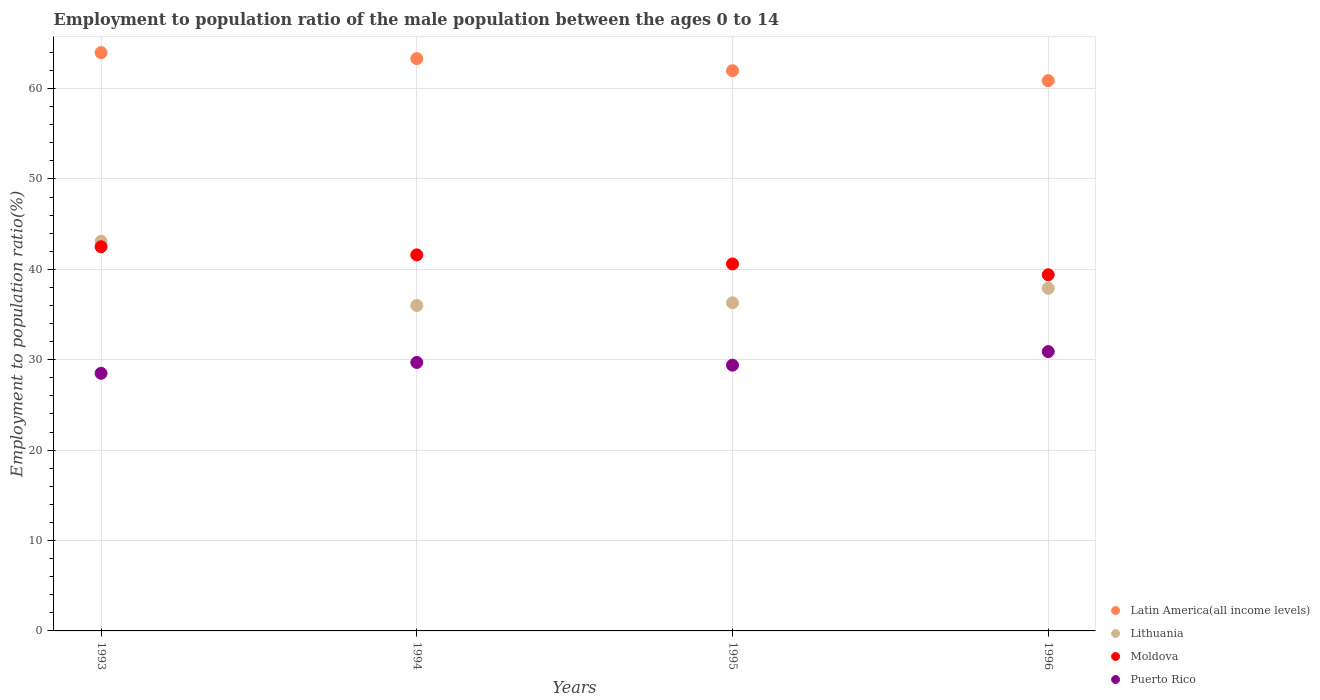What is the employment to population ratio in Puerto Rico in 1996?
Offer a terse response. 30.9. Across all years, what is the maximum employment to population ratio in Moldova?
Offer a very short reply. 42.5. Across all years, what is the minimum employment to population ratio in Puerto Rico?
Your answer should be very brief. 28.5. In which year was the employment to population ratio in Latin America(all income levels) maximum?
Keep it short and to the point. 1993. What is the total employment to population ratio in Moldova in the graph?
Your answer should be very brief. 164.1. What is the difference between the employment to population ratio in Latin America(all income levels) in 1994 and that in 1996?
Make the answer very short. 2.44. What is the difference between the employment to population ratio in Puerto Rico in 1993 and the employment to population ratio in Lithuania in 1995?
Your answer should be compact. -7.8. What is the average employment to population ratio in Puerto Rico per year?
Ensure brevity in your answer.  29.63. In how many years, is the employment to population ratio in Latin America(all income levels) greater than 56 %?
Give a very brief answer. 4. What is the ratio of the employment to population ratio in Lithuania in 1993 to that in 1995?
Provide a succinct answer. 1.19. Is the difference between the employment to population ratio in Moldova in 1993 and 1994 greater than the difference between the employment to population ratio in Puerto Rico in 1993 and 1994?
Your response must be concise. Yes. What is the difference between the highest and the second highest employment to population ratio in Lithuania?
Give a very brief answer. 5.2. What is the difference between the highest and the lowest employment to population ratio in Latin America(all income levels)?
Your response must be concise. 3.1. Is it the case that in every year, the sum of the employment to population ratio in Moldova and employment to population ratio in Lithuania  is greater than the sum of employment to population ratio in Latin America(all income levels) and employment to population ratio in Puerto Rico?
Provide a short and direct response. Yes. Is the employment to population ratio in Latin America(all income levels) strictly greater than the employment to population ratio in Lithuania over the years?
Offer a terse response. Yes. Does the graph contain grids?
Ensure brevity in your answer.  Yes. What is the title of the graph?
Give a very brief answer. Employment to population ratio of the male population between the ages 0 to 14. Does "Morocco" appear as one of the legend labels in the graph?
Provide a succinct answer. No. What is the label or title of the Y-axis?
Provide a succinct answer. Employment to population ratio(%). What is the Employment to population ratio(%) of Latin America(all income levels) in 1993?
Your answer should be very brief. 63.98. What is the Employment to population ratio(%) of Lithuania in 1993?
Your answer should be very brief. 43.1. What is the Employment to population ratio(%) of Moldova in 1993?
Your response must be concise. 42.5. What is the Employment to population ratio(%) in Latin America(all income levels) in 1994?
Your answer should be very brief. 63.31. What is the Employment to population ratio(%) in Moldova in 1994?
Offer a terse response. 41.6. What is the Employment to population ratio(%) in Puerto Rico in 1994?
Ensure brevity in your answer.  29.7. What is the Employment to population ratio(%) in Latin America(all income levels) in 1995?
Ensure brevity in your answer.  61.98. What is the Employment to population ratio(%) in Lithuania in 1995?
Your answer should be compact. 36.3. What is the Employment to population ratio(%) of Moldova in 1995?
Keep it short and to the point. 40.6. What is the Employment to population ratio(%) of Puerto Rico in 1995?
Offer a terse response. 29.4. What is the Employment to population ratio(%) in Latin America(all income levels) in 1996?
Ensure brevity in your answer.  60.87. What is the Employment to population ratio(%) of Lithuania in 1996?
Your response must be concise. 37.9. What is the Employment to population ratio(%) of Moldova in 1996?
Offer a terse response. 39.4. What is the Employment to population ratio(%) of Puerto Rico in 1996?
Your answer should be very brief. 30.9. Across all years, what is the maximum Employment to population ratio(%) of Latin America(all income levels)?
Provide a short and direct response. 63.98. Across all years, what is the maximum Employment to population ratio(%) of Lithuania?
Provide a short and direct response. 43.1. Across all years, what is the maximum Employment to population ratio(%) of Moldova?
Offer a very short reply. 42.5. Across all years, what is the maximum Employment to population ratio(%) in Puerto Rico?
Your response must be concise. 30.9. Across all years, what is the minimum Employment to population ratio(%) in Latin America(all income levels)?
Give a very brief answer. 60.87. Across all years, what is the minimum Employment to population ratio(%) of Lithuania?
Provide a succinct answer. 36. Across all years, what is the minimum Employment to population ratio(%) in Moldova?
Your answer should be compact. 39.4. Across all years, what is the minimum Employment to population ratio(%) in Puerto Rico?
Ensure brevity in your answer.  28.5. What is the total Employment to population ratio(%) of Latin America(all income levels) in the graph?
Your answer should be very brief. 250.14. What is the total Employment to population ratio(%) of Lithuania in the graph?
Provide a succinct answer. 153.3. What is the total Employment to population ratio(%) in Moldova in the graph?
Make the answer very short. 164.1. What is the total Employment to population ratio(%) of Puerto Rico in the graph?
Provide a succinct answer. 118.5. What is the difference between the Employment to population ratio(%) in Latin America(all income levels) in 1993 and that in 1994?
Offer a very short reply. 0.67. What is the difference between the Employment to population ratio(%) in Lithuania in 1993 and that in 1994?
Your answer should be compact. 7.1. What is the difference between the Employment to population ratio(%) of Latin America(all income levels) in 1993 and that in 1995?
Keep it short and to the point. 2. What is the difference between the Employment to population ratio(%) of Latin America(all income levels) in 1993 and that in 1996?
Offer a very short reply. 3.1. What is the difference between the Employment to population ratio(%) in Lithuania in 1993 and that in 1996?
Keep it short and to the point. 5.2. What is the difference between the Employment to population ratio(%) of Moldova in 1993 and that in 1996?
Provide a succinct answer. 3.1. What is the difference between the Employment to population ratio(%) of Puerto Rico in 1993 and that in 1996?
Your answer should be very brief. -2.4. What is the difference between the Employment to population ratio(%) in Latin America(all income levels) in 1994 and that in 1995?
Keep it short and to the point. 1.33. What is the difference between the Employment to population ratio(%) in Latin America(all income levels) in 1994 and that in 1996?
Your answer should be compact. 2.44. What is the difference between the Employment to population ratio(%) in Lithuania in 1994 and that in 1996?
Provide a succinct answer. -1.9. What is the difference between the Employment to population ratio(%) of Moldova in 1994 and that in 1996?
Your answer should be very brief. 2.2. What is the difference between the Employment to population ratio(%) of Latin America(all income levels) in 1995 and that in 1996?
Your response must be concise. 1.1. What is the difference between the Employment to population ratio(%) of Lithuania in 1995 and that in 1996?
Offer a terse response. -1.6. What is the difference between the Employment to population ratio(%) of Puerto Rico in 1995 and that in 1996?
Offer a terse response. -1.5. What is the difference between the Employment to population ratio(%) of Latin America(all income levels) in 1993 and the Employment to population ratio(%) of Lithuania in 1994?
Keep it short and to the point. 27.98. What is the difference between the Employment to population ratio(%) of Latin America(all income levels) in 1993 and the Employment to population ratio(%) of Moldova in 1994?
Offer a terse response. 22.38. What is the difference between the Employment to population ratio(%) in Latin America(all income levels) in 1993 and the Employment to population ratio(%) in Puerto Rico in 1994?
Your response must be concise. 34.28. What is the difference between the Employment to population ratio(%) of Latin America(all income levels) in 1993 and the Employment to population ratio(%) of Lithuania in 1995?
Offer a very short reply. 27.68. What is the difference between the Employment to population ratio(%) in Latin America(all income levels) in 1993 and the Employment to population ratio(%) in Moldova in 1995?
Make the answer very short. 23.38. What is the difference between the Employment to population ratio(%) of Latin America(all income levels) in 1993 and the Employment to population ratio(%) of Puerto Rico in 1995?
Offer a terse response. 34.58. What is the difference between the Employment to population ratio(%) of Lithuania in 1993 and the Employment to population ratio(%) of Puerto Rico in 1995?
Offer a terse response. 13.7. What is the difference between the Employment to population ratio(%) of Latin America(all income levels) in 1993 and the Employment to population ratio(%) of Lithuania in 1996?
Provide a short and direct response. 26.08. What is the difference between the Employment to population ratio(%) in Latin America(all income levels) in 1993 and the Employment to population ratio(%) in Moldova in 1996?
Offer a terse response. 24.58. What is the difference between the Employment to population ratio(%) in Latin America(all income levels) in 1993 and the Employment to population ratio(%) in Puerto Rico in 1996?
Your answer should be very brief. 33.08. What is the difference between the Employment to population ratio(%) of Lithuania in 1993 and the Employment to population ratio(%) of Moldova in 1996?
Give a very brief answer. 3.7. What is the difference between the Employment to population ratio(%) of Latin America(all income levels) in 1994 and the Employment to population ratio(%) of Lithuania in 1995?
Offer a very short reply. 27.01. What is the difference between the Employment to population ratio(%) in Latin America(all income levels) in 1994 and the Employment to population ratio(%) in Moldova in 1995?
Your answer should be compact. 22.71. What is the difference between the Employment to population ratio(%) in Latin America(all income levels) in 1994 and the Employment to population ratio(%) in Puerto Rico in 1995?
Your answer should be compact. 33.91. What is the difference between the Employment to population ratio(%) of Lithuania in 1994 and the Employment to population ratio(%) of Moldova in 1995?
Your response must be concise. -4.6. What is the difference between the Employment to population ratio(%) of Latin America(all income levels) in 1994 and the Employment to population ratio(%) of Lithuania in 1996?
Give a very brief answer. 25.41. What is the difference between the Employment to population ratio(%) in Latin America(all income levels) in 1994 and the Employment to population ratio(%) in Moldova in 1996?
Offer a terse response. 23.91. What is the difference between the Employment to population ratio(%) in Latin America(all income levels) in 1994 and the Employment to population ratio(%) in Puerto Rico in 1996?
Offer a very short reply. 32.41. What is the difference between the Employment to population ratio(%) in Latin America(all income levels) in 1995 and the Employment to population ratio(%) in Lithuania in 1996?
Give a very brief answer. 24.08. What is the difference between the Employment to population ratio(%) of Latin America(all income levels) in 1995 and the Employment to population ratio(%) of Moldova in 1996?
Offer a very short reply. 22.58. What is the difference between the Employment to population ratio(%) of Latin America(all income levels) in 1995 and the Employment to population ratio(%) of Puerto Rico in 1996?
Make the answer very short. 31.08. What is the difference between the Employment to population ratio(%) of Lithuania in 1995 and the Employment to population ratio(%) of Moldova in 1996?
Your response must be concise. -3.1. What is the difference between the Employment to population ratio(%) of Moldova in 1995 and the Employment to population ratio(%) of Puerto Rico in 1996?
Your answer should be very brief. 9.7. What is the average Employment to population ratio(%) of Latin America(all income levels) per year?
Offer a very short reply. 62.53. What is the average Employment to population ratio(%) of Lithuania per year?
Make the answer very short. 38.33. What is the average Employment to population ratio(%) of Moldova per year?
Your response must be concise. 41.02. What is the average Employment to population ratio(%) in Puerto Rico per year?
Keep it short and to the point. 29.62. In the year 1993, what is the difference between the Employment to population ratio(%) of Latin America(all income levels) and Employment to population ratio(%) of Lithuania?
Keep it short and to the point. 20.88. In the year 1993, what is the difference between the Employment to population ratio(%) in Latin America(all income levels) and Employment to population ratio(%) in Moldova?
Provide a succinct answer. 21.48. In the year 1993, what is the difference between the Employment to population ratio(%) in Latin America(all income levels) and Employment to population ratio(%) in Puerto Rico?
Offer a terse response. 35.48. In the year 1993, what is the difference between the Employment to population ratio(%) of Lithuania and Employment to population ratio(%) of Puerto Rico?
Make the answer very short. 14.6. In the year 1993, what is the difference between the Employment to population ratio(%) in Moldova and Employment to population ratio(%) in Puerto Rico?
Make the answer very short. 14. In the year 1994, what is the difference between the Employment to population ratio(%) of Latin America(all income levels) and Employment to population ratio(%) of Lithuania?
Your answer should be compact. 27.31. In the year 1994, what is the difference between the Employment to population ratio(%) of Latin America(all income levels) and Employment to population ratio(%) of Moldova?
Your answer should be compact. 21.71. In the year 1994, what is the difference between the Employment to population ratio(%) of Latin America(all income levels) and Employment to population ratio(%) of Puerto Rico?
Your answer should be very brief. 33.61. In the year 1994, what is the difference between the Employment to population ratio(%) of Lithuania and Employment to population ratio(%) of Puerto Rico?
Keep it short and to the point. 6.3. In the year 1995, what is the difference between the Employment to population ratio(%) in Latin America(all income levels) and Employment to population ratio(%) in Lithuania?
Your answer should be very brief. 25.68. In the year 1995, what is the difference between the Employment to population ratio(%) in Latin America(all income levels) and Employment to population ratio(%) in Moldova?
Ensure brevity in your answer.  21.38. In the year 1995, what is the difference between the Employment to population ratio(%) in Latin America(all income levels) and Employment to population ratio(%) in Puerto Rico?
Give a very brief answer. 32.58. In the year 1995, what is the difference between the Employment to population ratio(%) in Lithuania and Employment to population ratio(%) in Moldova?
Your response must be concise. -4.3. In the year 1995, what is the difference between the Employment to population ratio(%) in Lithuania and Employment to population ratio(%) in Puerto Rico?
Your answer should be very brief. 6.9. In the year 1996, what is the difference between the Employment to population ratio(%) of Latin America(all income levels) and Employment to population ratio(%) of Lithuania?
Your response must be concise. 22.97. In the year 1996, what is the difference between the Employment to population ratio(%) in Latin America(all income levels) and Employment to population ratio(%) in Moldova?
Offer a terse response. 21.47. In the year 1996, what is the difference between the Employment to population ratio(%) in Latin America(all income levels) and Employment to population ratio(%) in Puerto Rico?
Your answer should be very brief. 29.97. In the year 1996, what is the difference between the Employment to population ratio(%) in Lithuania and Employment to population ratio(%) in Puerto Rico?
Your answer should be compact. 7. What is the ratio of the Employment to population ratio(%) in Latin America(all income levels) in 1993 to that in 1994?
Your answer should be very brief. 1.01. What is the ratio of the Employment to population ratio(%) of Lithuania in 1993 to that in 1994?
Make the answer very short. 1.2. What is the ratio of the Employment to population ratio(%) in Moldova in 1993 to that in 1994?
Offer a terse response. 1.02. What is the ratio of the Employment to population ratio(%) of Puerto Rico in 1993 to that in 1994?
Offer a terse response. 0.96. What is the ratio of the Employment to population ratio(%) in Latin America(all income levels) in 1993 to that in 1995?
Ensure brevity in your answer.  1.03. What is the ratio of the Employment to population ratio(%) in Lithuania in 1993 to that in 1995?
Make the answer very short. 1.19. What is the ratio of the Employment to population ratio(%) of Moldova in 1993 to that in 1995?
Offer a very short reply. 1.05. What is the ratio of the Employment to population ratio(%) of Puerto Rico in 1993 to that in 1995?
Give a very brief answer. 0.97. What is the ratio of the Employment to population ratio(%) in Latin America(all income levels) in 1993 to that in 1996?
Keep it short and to the point. 1.05. What is the ratio of the Employment to population ratio(%) of Lithuania in 1993 to that in 1996?
Give a very brief answer. 1.14. What is the ratio of the Employment to population ratio(%) of Moldova in 1993 to that in 1996?
Offer a very short reply. 1.08. What is the ratio of the Employment to population ratio(%) in Puerto Rico in 1993 to that in 1996?
Your response must be concise. 0.92. What is the ratio of the Employment to population ratio(%) of Latin America(all income levels) in 1994 to that in 1995?
Offer a very short reply. 1.02. What is the ratio of the Employment to population ratio(%) in Moldova in 1994 to that in 1995?
Provide a short and direct response. 1.02. What is the ratio of the Employment to population ratio(%) of Puerto Rico in 1994 to that in 1995?
Ensure brevity in your answer.  1.01. What is the ratio of the Employment to population ratio(%) in Latin America(all income levels) in 1994 to that in 1996?
Keep it short and to the point. 1.04. What is the ratio of the Employment to population ratio(%) in Lithuania in 1994 to that in 1996?
Offer a very short reply. 0.95. What is the ratio of the Employment to population ratio(%) in Moldova in 1994 to that in 1996?
Give a very brief answer. 1.06. What is the ratio of the Employment to population ratio(%) of Puerto Rico in 1994 to that in 1996?
Offer a terse response. 0.96. What is the ratio of the Employment to population ratio(%) in Latin America(all income levels) in 1995 to that in 1996?
Make the answer very short. 1.02. What is the ratio of the Employment to population ratio(%) in Lithuania in 1995 to that in 1996?
Ensure brevity in your answer.  0.96. What is the ratio of the Employment to population ratio(%) of Moldova in 1995 to that in 1996?
Keep it short and to the point. 1.03. What is the ratio of the Employment to population ratio(%) of Puerto Rico in 1995 to that in 1996?
Your response must be concise. 0.95. What is the difference between the highest and the second highest Employment to population ratio(%) of Latin America(all income levels)?
Keep it short and to the point. 0.67. What is the difference between the highest and the second highest Employment to population ratio(%) in Puerto Rico?
Your response must be concise. 1.2. What is the difference between the highest and the lowest Employment to population ratio(%) of Latin America(all income levels)?
Provide a succinct answer. 3.1. What is the difference between the highest and the lowest Employment to population ratio(%) of Lithuania?
Provide a short and direct response. 7.1. What is the difference between the highest and the lowest Employment to population ratio(%) of Moldova?
Provide a succinct answer. 3.1. 